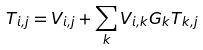<formula> <loc_0><loc_0><loc_500><loc_500>T _ { i , j } = V _ { i , j } + \sum _ { k } V _ { i , k } G _ { k } T _ { k , j }</formula> 